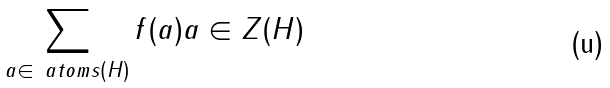Convert formula to latex. <formula><loc_0><loc_0><loc_500><loc_500>\sum _ { a \in \ a t o m s ( H ) } f ( a ) a \in Z ( H )</formula> 